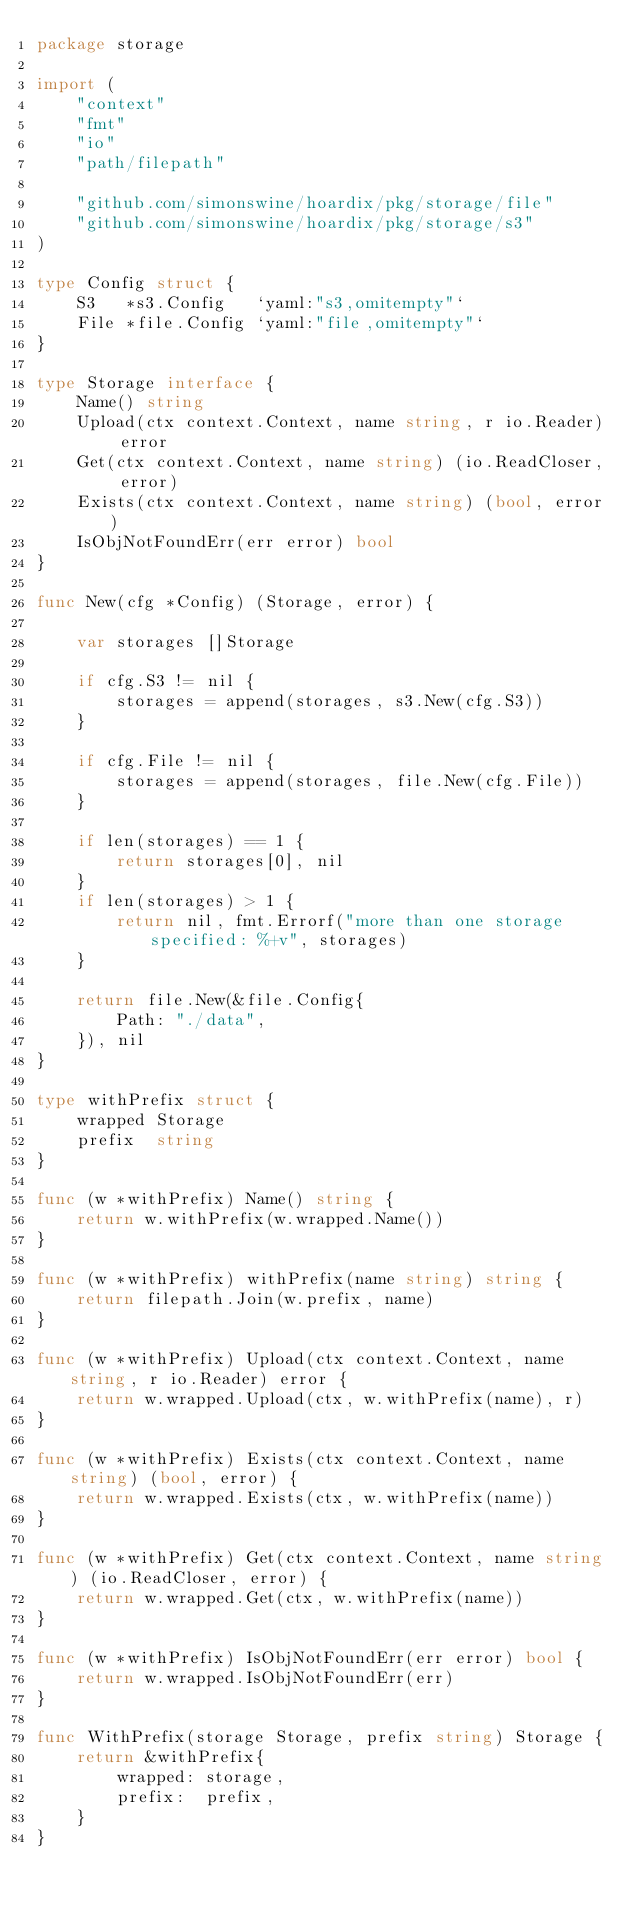<code> <loc_0><loc_0><loc_500><loc_500><_Go_>package storage

import (
	"context"
	"fmt"
	"io"
	"path/filepath"

	"github.com/simonswine/hoardix/pkg/storage/file"
	"github.com/simonswine/hoardix/pkg/storage/s3"
)

type Config struct {
	S3   *s3.Config   `yaml:"s3,omitempty"`
	File *file.Config `yaml:"file,omitempty"`
}

type Storage interface {
	Name() string
	Upload(ctx context.Context, name string, r io.Reader) error
	Get(ctx context.Context, name string) (io.ReadCloser, error)
	Exists(ctx context.Context, name string) (bool, error)
	IsObjNotFoundErr(err error) bool
}

func New(cfg *Config) (Storage, error) {

	var storages []Storage

	if cfg.S3 != nil {
		storages = append(storages, s3.New(cfg.S3))
	}

	if cfg.File != nil {
		storages = append(storages, file.New(cfg.File))
	}

	if len(storages) == 1 {
		return storages[0], nil
	}
	if len(storages) > 1 {
		return nil, fmt.Errorf("more than one storage specified: %+v", storages)
	}

	return file.New(&file.Config{
		Path: "./data",
	}), nil
}

type withPrefix struct {
	wrapped Storage
	prefix  string
}

func (w *withPrefix) Name() string {
	return w.withPrefix(w.wrapped.Name())
}

func (w *withPrefix) withPrefix(name string) string {
	return filepath.Join(w.prefix, name)
}

func (w *withPrefix) Upload(ctx context.Context, name string, r io.Reader) error {
	return w.wrapped.Upload(ctx, w.withPrefix(name), r)
}

func (w *withPrefix) Exists(ctx context.Context, name string) (bool, error) {
	return w.wrapped.Exists(ctx, w.withPrefix(name))
}

func (w *withPrefix) Get(ctx context.Context, name string) (io.ReadCloser, error) {
	return w.wrapped.Get(ctx, w.withPrefix(name))
}

func (w *withPrefix) IsObjNotFoundErr(err error) bool {
	return w.wrapped.IsObjNotFoundErr(err)
}

func WithPrefix(storage Storage, prefix string) Storage {
	return &withPrefix{
		wrapped: storage,
		prefix:  prefix,
	}
}
</code> 